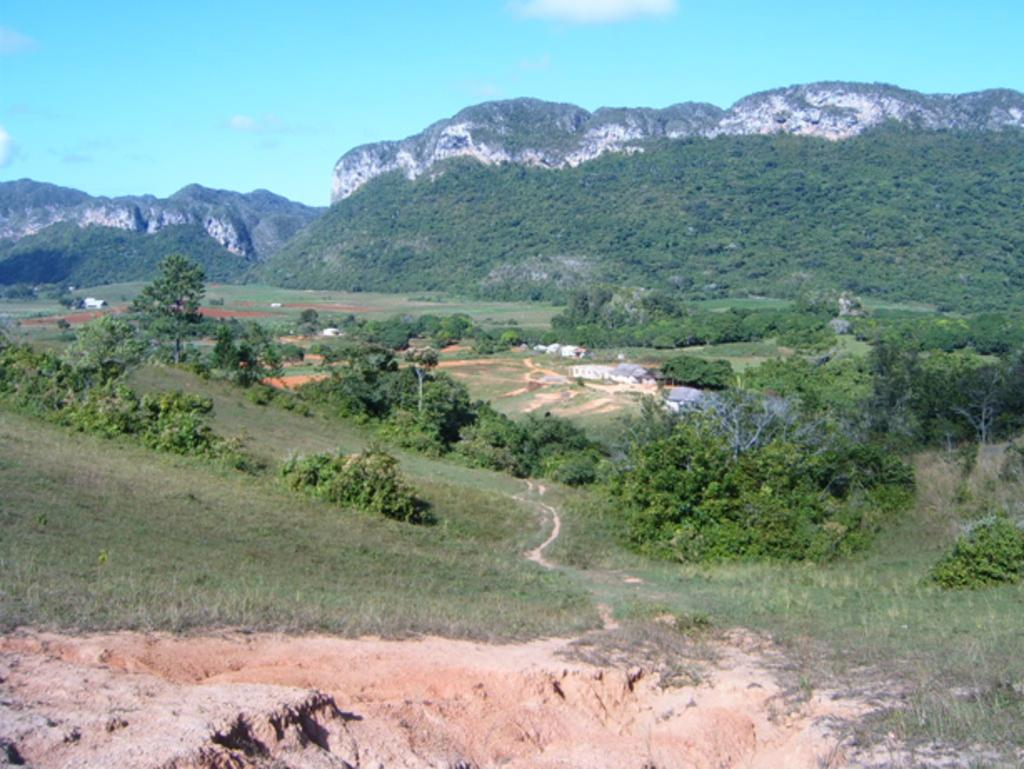What can be seen in the background of the image? The sky, hills, and thicket can be seen in the background of the image. What type of vegetation is present in the image? There are trees in the image. What is visible on the ground in the image? The ground is visible in the image, and there is green grass. Can you see a snake slithering through the linen in the image? There is no snake or linen present in the image. 